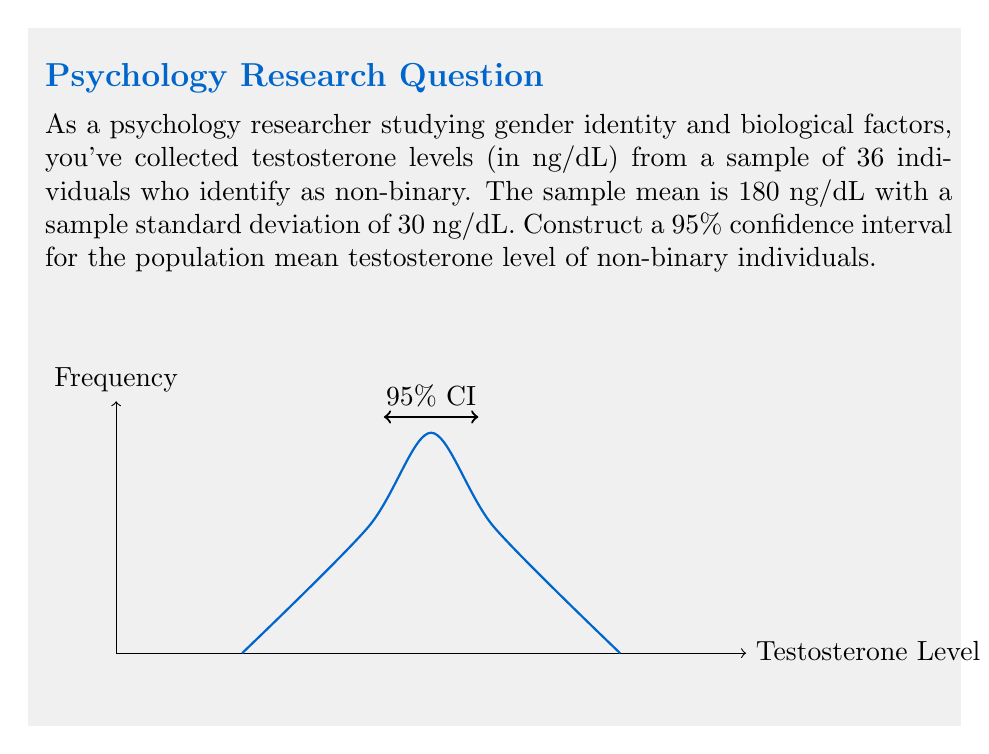Show me your answer to this math problem. To construct a confidence interval, we'll use the t-distribution since we don't know the population standard deviation. Let's follow these steps:

1) The formula for the confidence interval is:

   $$\bar{x} \pm t_{\alpha/2, n-1} \cdot \frac{s}{\sqrt{n}}$$

   where $\bar{x}$ is the sample mean, $s$ is the sample standard deviation, $n$ is the sample size, and $t_{\alpha/2, n-1}$ is the t-value for a 95% confidence level with $n-1$ degrees of freedom.

2) We know:
   $\bar{x} = 180$ ng/dL
   $s = 30$ ng/dL
   $n = 36$
   Confidence level = 95%, so $\alpha = 0.05$

3) Degrees of freedom = $n - 1 = 36 - 1 = 35$

4) From a t-table or calculator, we find $t_{0.025, 35} \approx 2.030$

5) Now we can calculate the margin of error:

   $$2.030 \cdot \frac{30}{\sqrt{36}} \approx 10.15$$

6) Therefore, the confidence interval is:

   $$180 \pm 10.15$$

7) This gives us the interval (169.85, 190.15)
Answer: (169.85, 190.15) ng/dL 